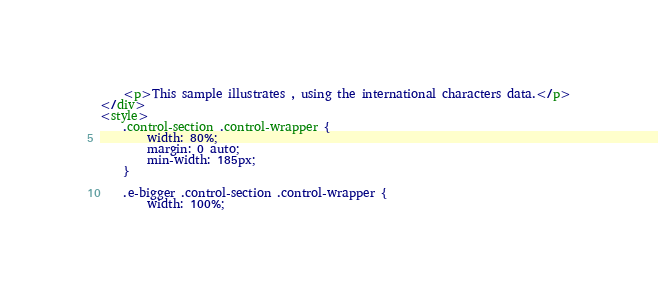Convert code to text. <code><loc_0><loc_0><loc_500><loc_500><_HTML_>
    <p>This sample illustrates , using the international characters data.</p>
</div>
<style>
    .control-section .control-wrapper {
        width: 80%;
        margin: 0 auto;
        min-width: 185px;
    }

    .e-bigger .control-section .control-wrapper {
        width: 100%;</code> 